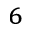<formula> <loc_0><loc_0><loc_500><loc_500>^ { 6 }</formula> 